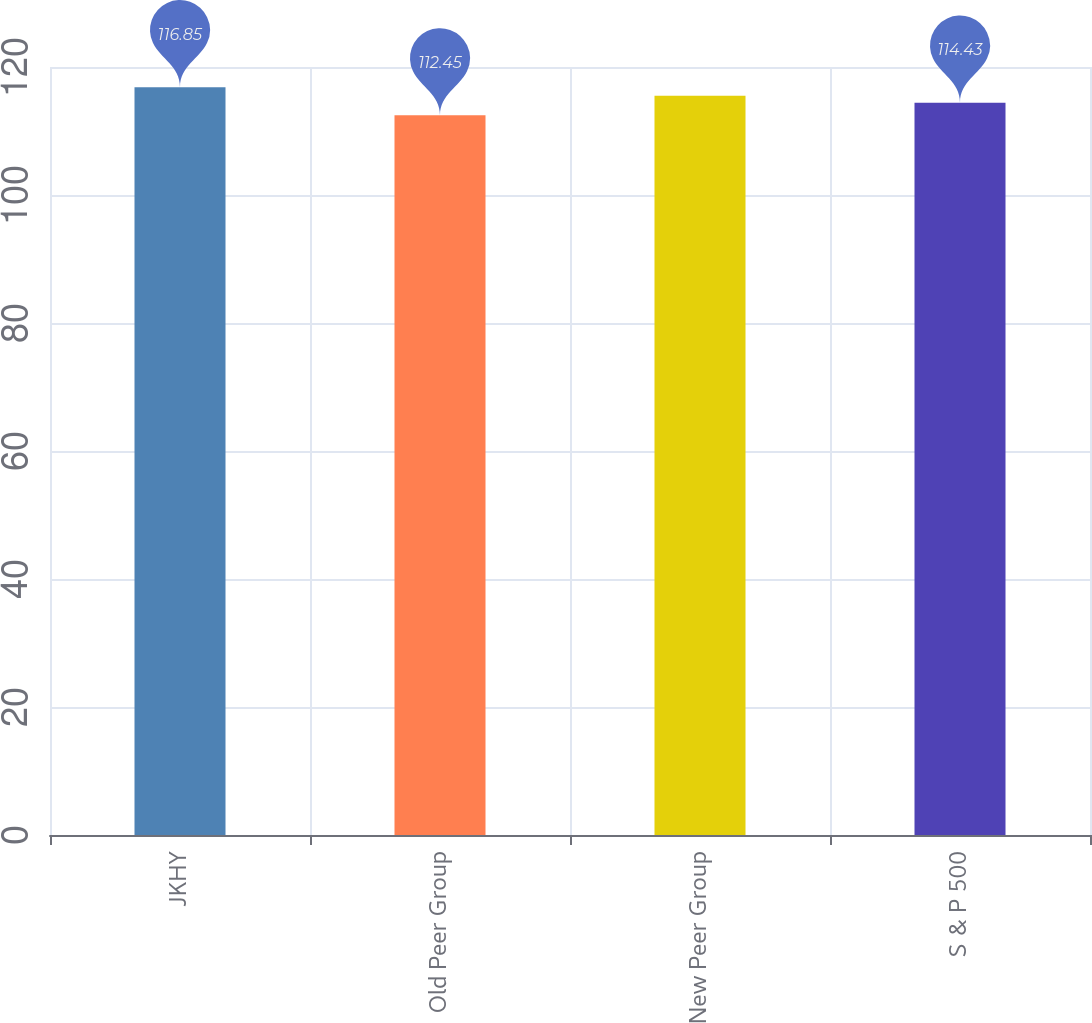Convert chart to OTSL. <chart><loc_0><loc_0><loc_500><loc_500><bar_chart><fcel>JKHY<fcel>Old Peer Group<fcel>New Peer Group<fcel>S & P 500<nl><fcel>116.85<fcel>112.45<fcel>115.5<fcel>114.43<nl></chart> 